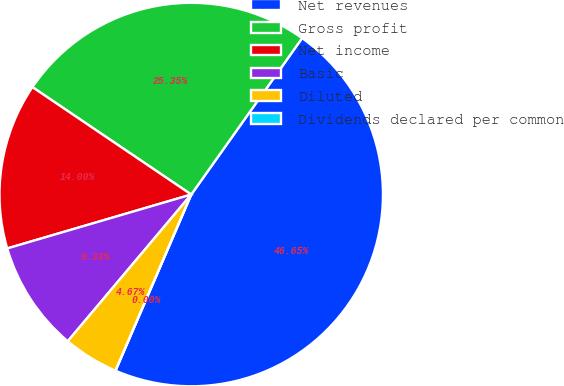Convert chart to OTSL. <chart><loc_0><loc_0><loc_500><loc_500><pie_chart><fcel>Net revenues<fcel>Gross profit<fcel>Net income<fcel>Basic<fcel>Diluted<fcel>Dividends declared per common<nl><fcel>46.65%<fcel>25.35%<fcel>14.0%<fcel>9.33%<fcel>4.67%<fcel>0.0%<nl></chart> 